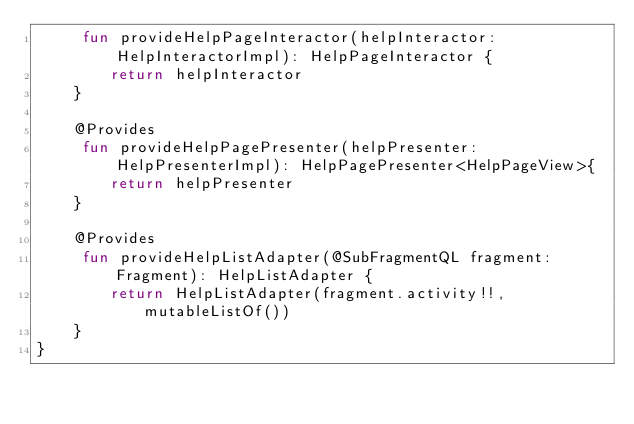Convert code to text. <code><loc_0><loc_0><loc_500><loc_500><_Kotlin_>     fun provideHelpPageInteractor(helpInteractor: HelpInteractorImpl): HelpPageInteractor {
        return helpInteractor
    }

    @Provides
     fun provideHelpPagePresenter(helpPresenter: HelpPresenterImpl): HelpPagePresenter<HelpPageView>{
        return helpPresenter
    }

    @Provides
     fun provideHelpListAdapter(@SubFragmentQL fragment: Fragment): HelpListAdapter {
        return HelpListAdapter(fragment.activity!!, mutableListOf())
    }
}
</code> 